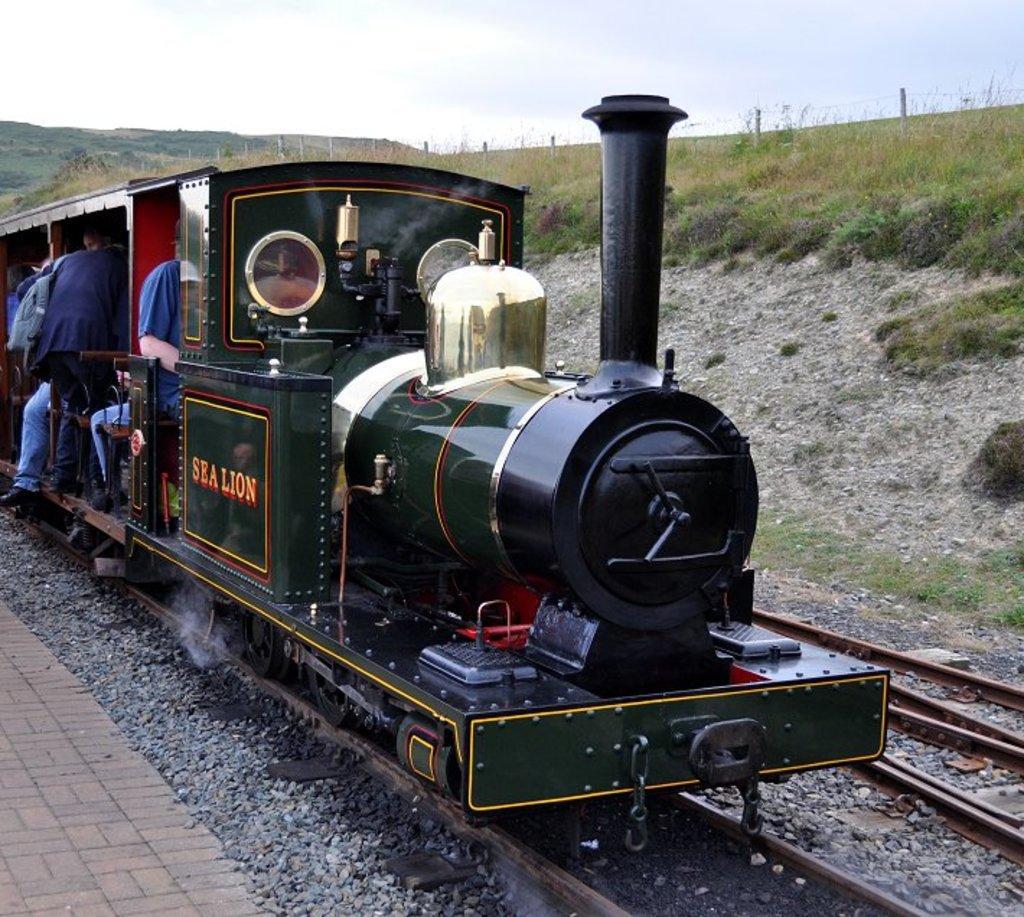In one or two sentences, can you explain what this image depicts? In this image, we can see two railway tracks, there is a train, there are some people sitting in the train, at the right side we can see green grass, at the top there is a sky. 